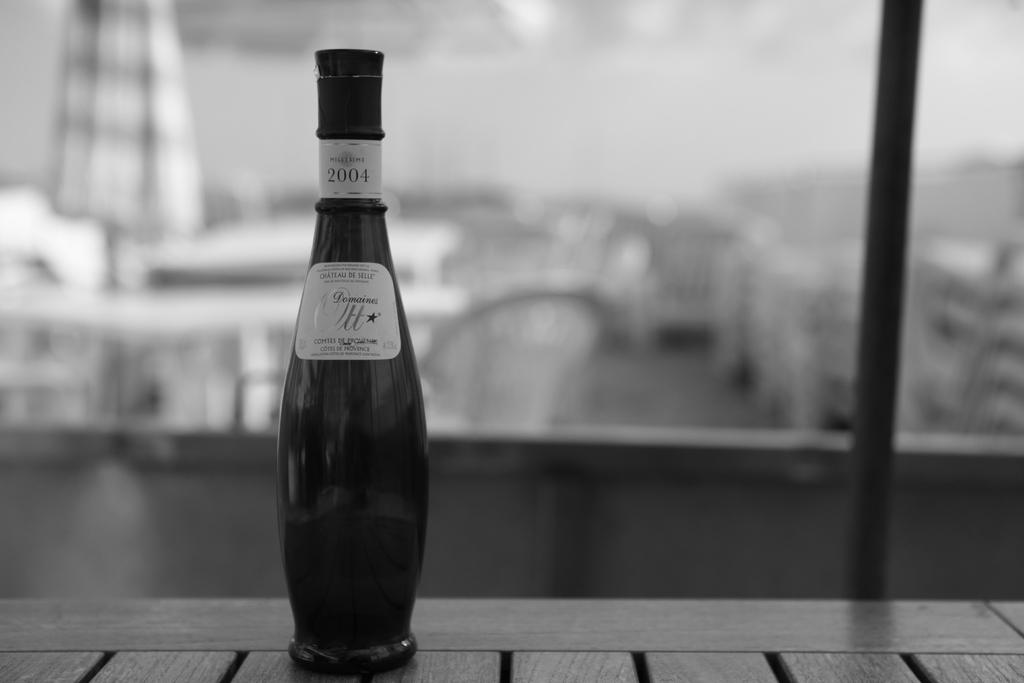<image>
Create a compact narrative representing the image presented. The label on a bottle of wine includes Ott in it. 